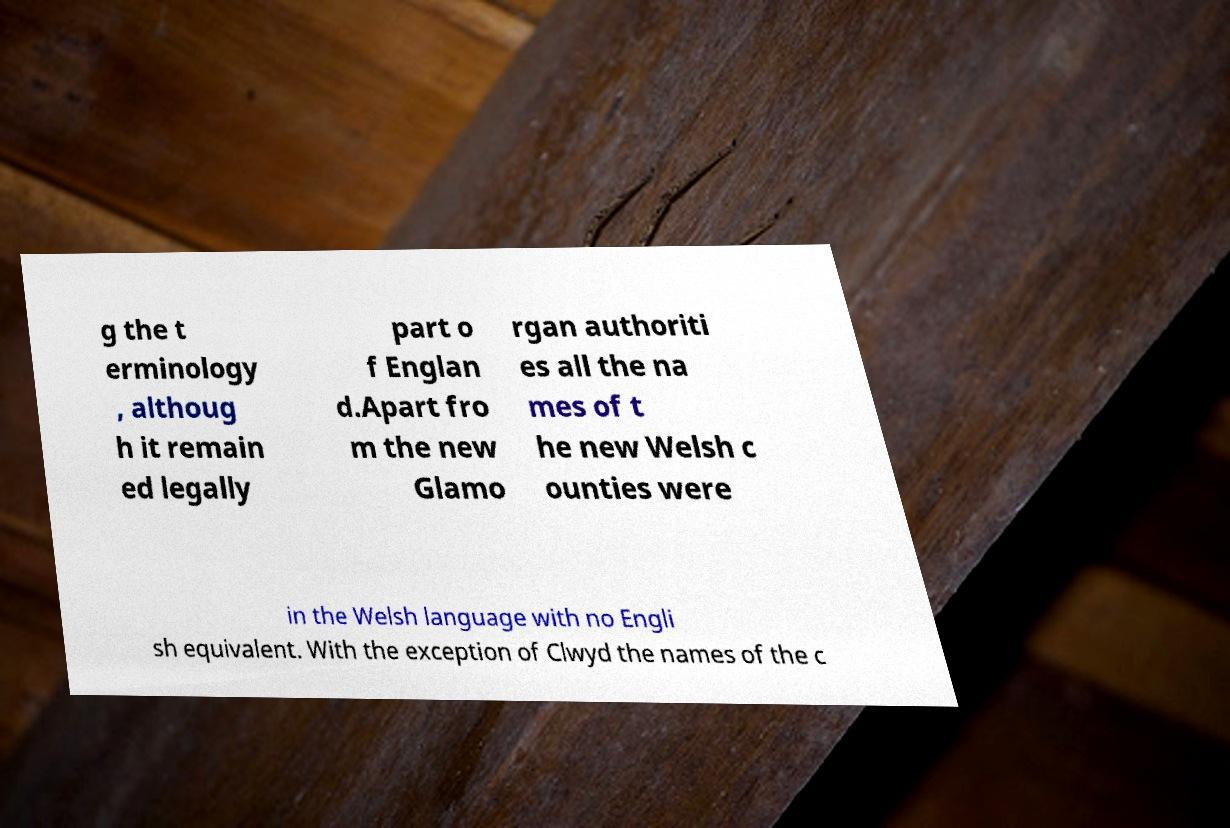Can you read and provide the text displayed in the image?This photo seems to have some interesting text. Can you extract and type it out for me? g the t erminology , althoug h it remain ed legally part o f Englan d.Apart fro m the new Glamo rgan authoriti es all the na mes of t he new Welsh c ounties were in the Welsh language with no Engli sh equivalent. With the exception of Clwyd the names of the c 